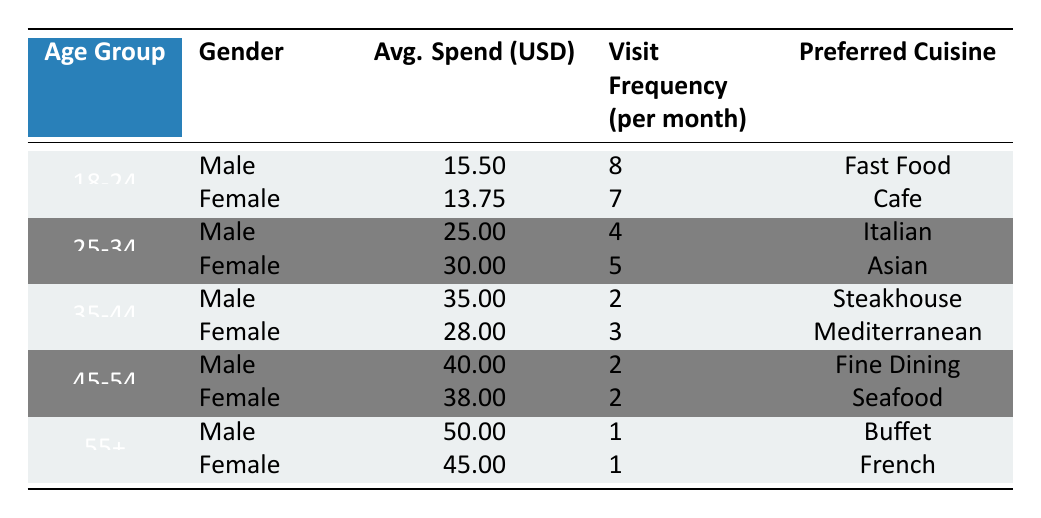What is the average spend for males in the 25-34 age group? In the 25-34 age group, the average spend for males is listed as 25.00 USD.
Answer: 25.00 USD Which gender spends more on average in the 35-44 age group? For the 35-44 age group, the average spend for males is 35.00 USD, while for females it is 28.00 USD. Therefore, males spend more on average.
Answer: Male What is the total average spend for females across all age groups? The average spends for females in each age group are: 13.75 (18-24) + 30.00 (25-34) + 28.00 (35-44) + 38.00 (45-54) + 45.00 (55+) = 154.75 USD. There are 5 age groups, so the average total is 154.75 / 5 = 30.95 USD.
Answer: 30.95 USD Is it true that customers aged 55+ spend the most on average? For customers aged 55+, the average spends are 50.00 USD for males and 45.00 USD for females. This is higher than all other age groups, where the maximum spend is 40.00 USD. Thus, it is true that customers aged 55+ spend the most on average.
Answer: Yes What is the average frequency of visits per month for the 18-24 age group? For the 18-24 age group, males visit an average of 8 times per month, and females visit an average of 7 times per month. To find the overall average, (8 + 7) / 2 = 7.5 visits per month.
Answer: 7.5 visits 